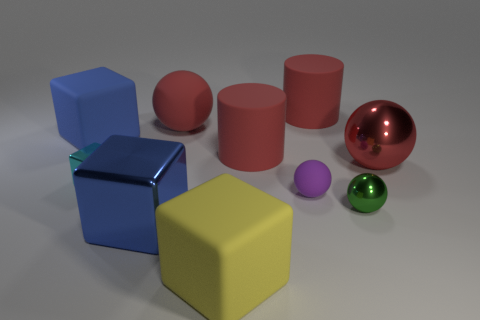What could these objects represent in a metaphorical or symbolic way? Metaphorically, these objects could represent diversity and individuality, symbolizing how various unique elements come together to form a cohesive whole. Additionally, the arrangement might symbolize structure and balance. 